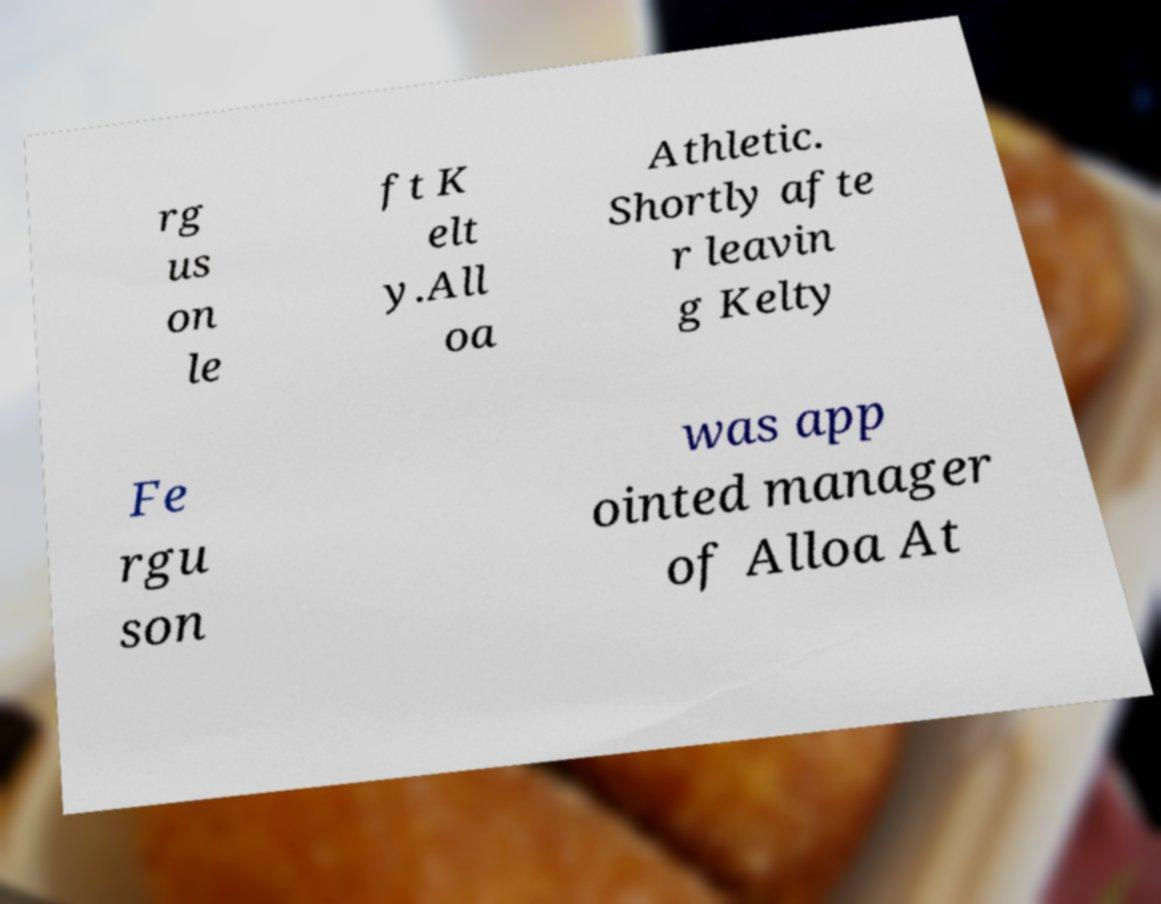Can you accurately transcribe the text from the provided image for me? rg us on le ft K elt y.All oa Athletic. Shortly afte r leavin g Kelty Fe rgu son was app ointed manager of Alloa At 